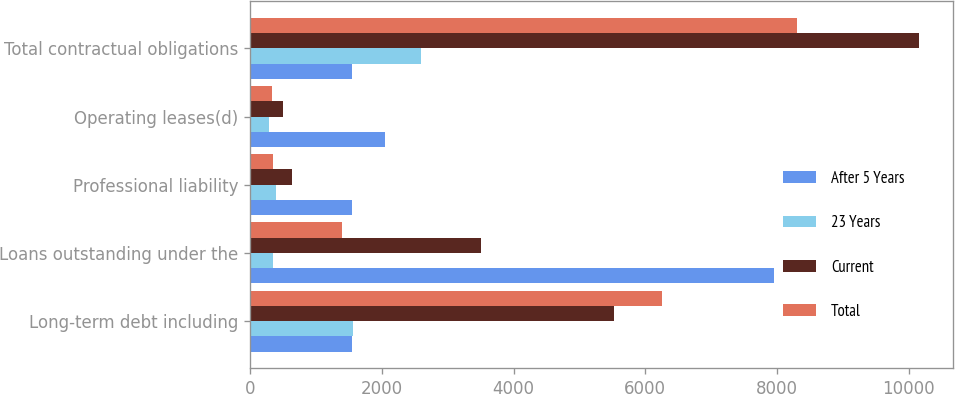Convert chart to OTSL. <chart><loc_0><loc_0><loc_500><loc_500><stacked_bar_chart><ecel><fcel>Long-term debt including<fcel>Loans outstanding under the<fcel>Professional liability<fcel>Operating leases(d)<fcel>Total contractual obligations<nl><fcel>After 5 Years<fcel>1547.5<fcel>7953<fcel>1539<fcel>2050<fcel>1547.5<nl><fcel>23 Years<fcel>1556<fcel>338<fcel>391<fcel>288<fcel>2593<nl><fcel>Current<fcel>5518<fcel>3508<fcel>640<fcel>497<fcel>10165<nl><fcel>Total<fcel>6253<fcel>1389<fcel>344<fcel>327<fcel>8313<nl></chart> 